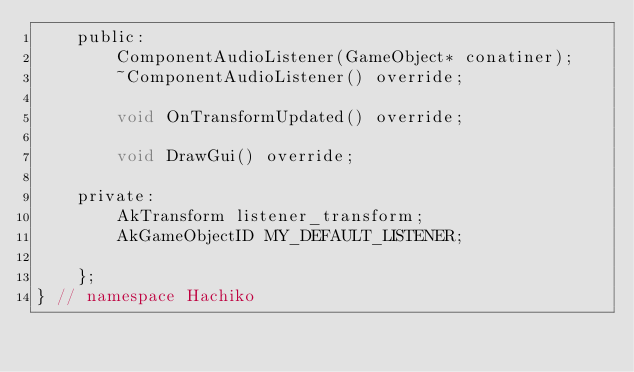<code> <loc_0><loc_0><loc_500><loc_500><_C_>    public:
        ComponentAudioListener(GameObject* conatiner);
        ~ComponentAudioListener() override;
        
        void OnTransformUpdated() override;

        void DrawGui() override;  

    private:
        AkTransform listener_transform;
        AkGameObjectID MY_DEFAULT_LISTENER;

    };
} // namespace Hachiko
</code> 